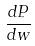Convert formula to latex. <formula><loc_0><loc_0><loc_500><loc_500>\frac { d P } { d w }</formula> 